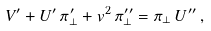Convert formula to latex. <formula><loc_0><loc_0><loc_500><loc_500>V ^ { \prime } + U ^ { \prime } \, \pi _ { \perp } ^ { \prime } + v ^ { 2 } \, \pi _ { \perp } ^ { \prime \prime } = \pi _ { \perp } \, U ^ { \prime \prime } \, ,</formula> 